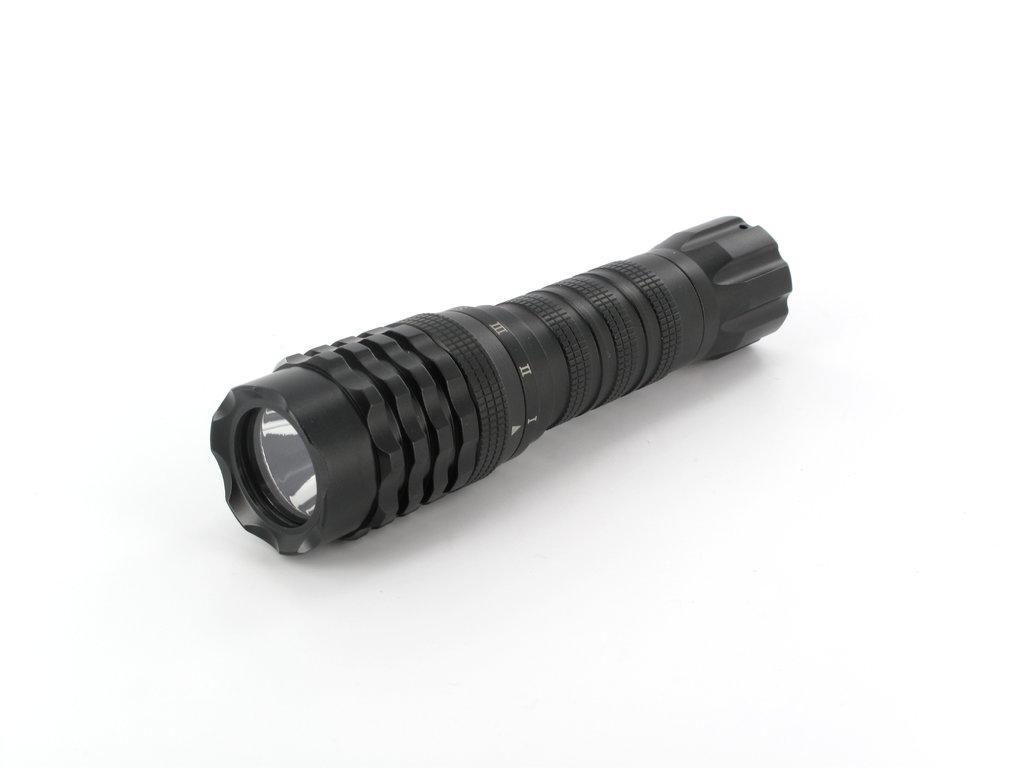In one or two sentences, can you explain what this image depicts? In this picture I can see a touch light. 